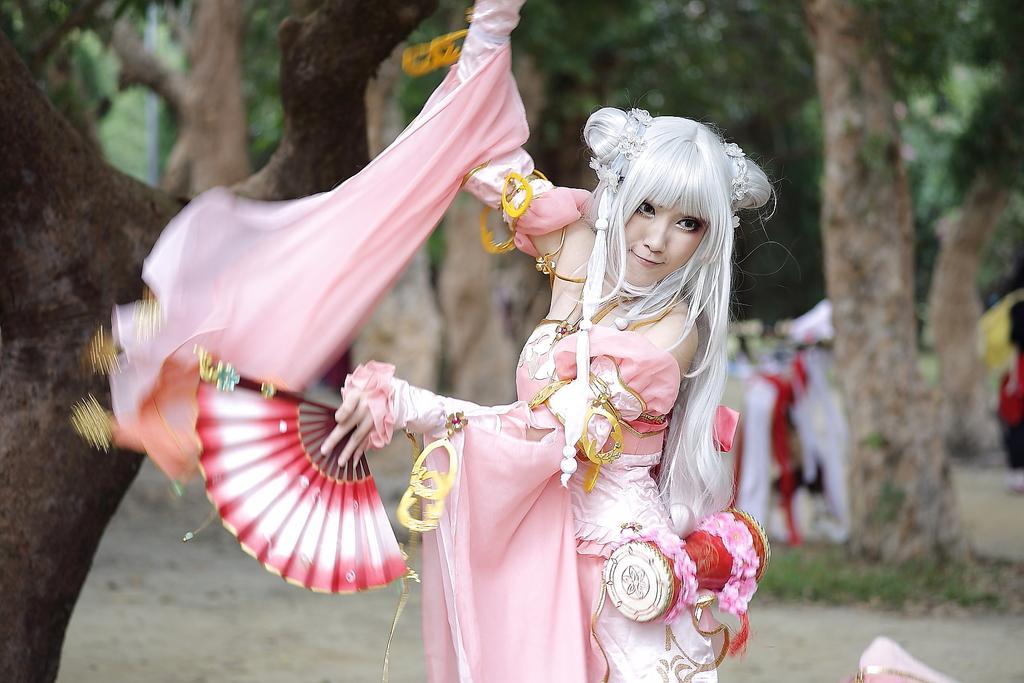Could you give a brief overview of what you see in this image? In this picture, we see a woman in the pink costume is standing and she is holding a hand fan in her hands. I think she is dancing. Behind her, we see the clothes in white and red color. On the left side, we see the stem of a tree. On the right side, we see a person is standing and we see a cloth in yellow color. At the bottom, we see the road. There are trees in the background and this picture is blurred in the background. 